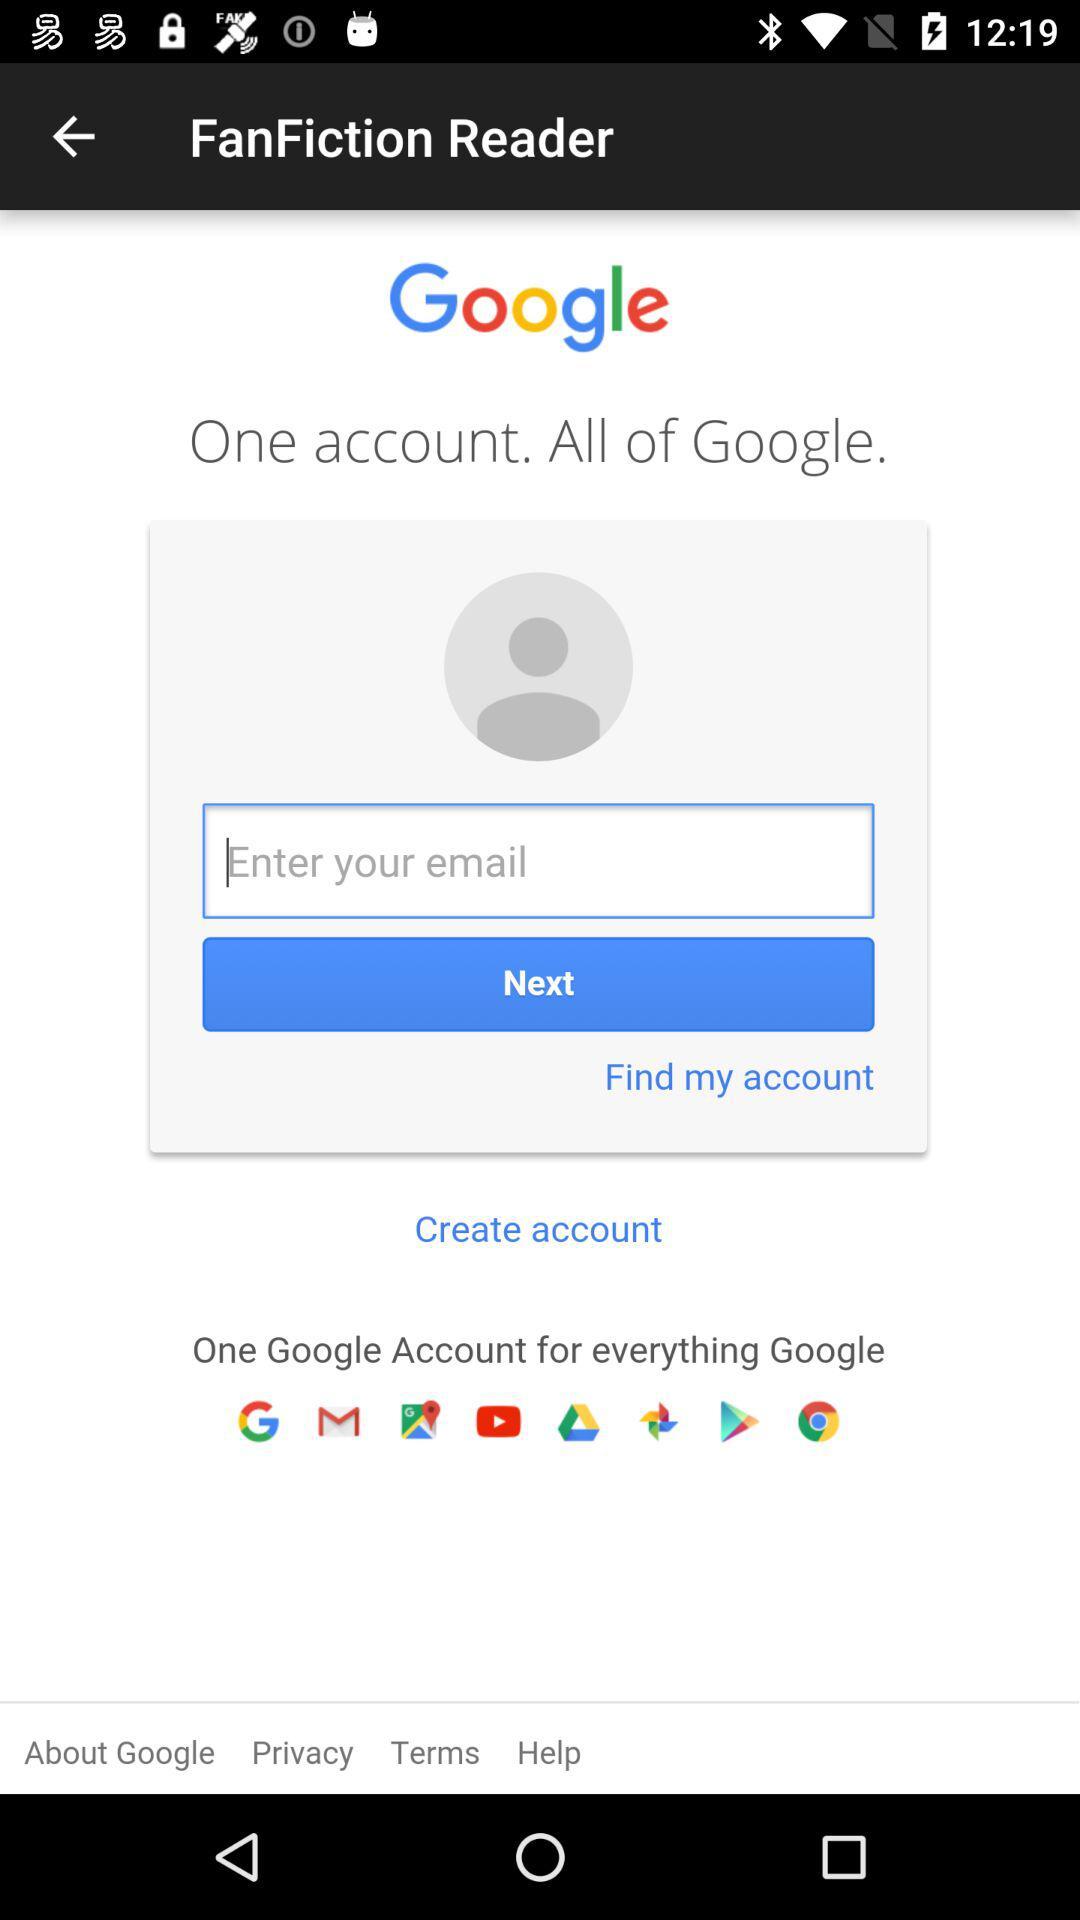What is the app name? The app name is "FanFiction Reader". 